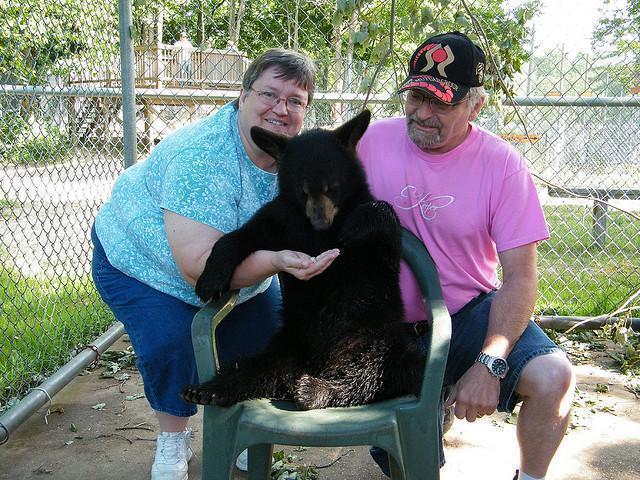What is the woman doing with the bear?
Indicate the correct response by choosing from the four available options to answer the question.
Options: Cleaning it, feeding it, smothering it, fighting it. Feeding it. 